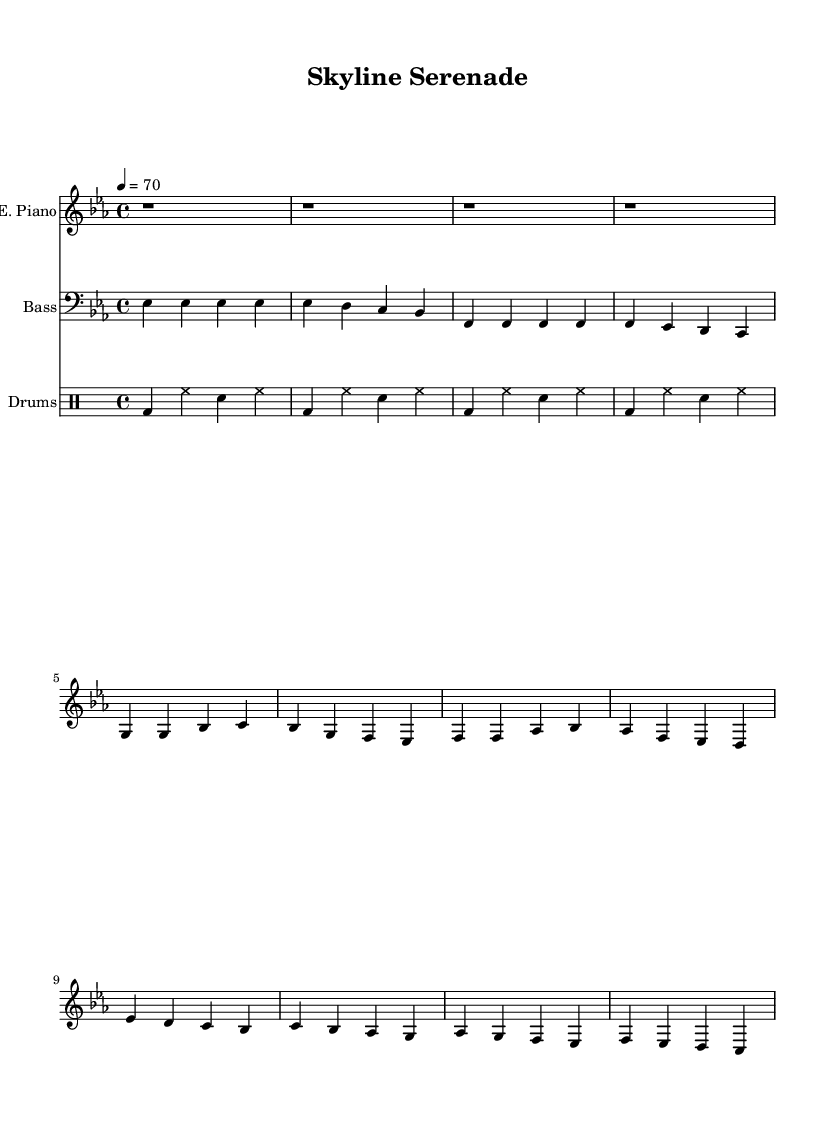What is the key signature of this music? The key signature is E flat major, which contains three flat notes: B flat, E flat, and A flat. This can be identified by looking at the key signature at the beginning of the sheet music.
Answer: E flat major What is the time signature of this music? The time signature is 4/4, which is indicated at the beginning of the music. This means there are four beats per measure, and the quarter note gets one beat.
Answer: 4/4 What is the tempo marking for this piece? The tempo is marked at 70 beats per minute, which can be found under the tempo indication at the beginning of the score. This indicates the speed at which the piece should be played.
Answer: 70 How many measures are in the electric piano part? There are 8 measures indicated in the electric piano part, which can be counted from the beginning of the part up to where it ends, with each group of notes representing a measure.
Answer: 8 What style best describes this music piece? The style is smooth soul, which can be inferred from the gentle melodic lines and the laid-back groove typical of the genre, as well as instrumentation like electric piano and bass guitar.
Answer: Smooth soul What is the primary rhythmic pattern used in the drum part? The primary rhythmic pattern consists of a bass drum on beats 1 and 3, with snare and hi-hat accents on beats 2 and 4, which establishes a groove typical of soul music.
Answer: Bass drum and hi-hat How is the melody structured in the electric piano part? The melody is structured around a sequence of stepwise motion with occasional leaps, creating a flowing and soulful expression that fits the genre's characteristics.
Answer: Stepwise motion 